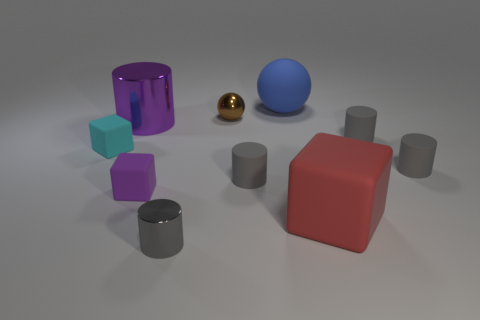How many gray cylinders must be subtracted to get 1 gray cylinders? 3 Subtract all yellow blocks. How many gray cylinders are left? 4 Subtract all blue cubes. Subtract all purple cylinders. How many cubes are left? 3 Subtract all spheres. How many objects are left? 8 Add 8 blue matte objects. How many blue matte objects are left? 9 Add 5 tiny green rubber cubes. How many tiny green rubber cubes exist? 5 Subtract 1 brown balls. How many objects are left? 9 Subtract all small gray metallic objects. Subtract all metallic spheres. How many objects are left? 8 